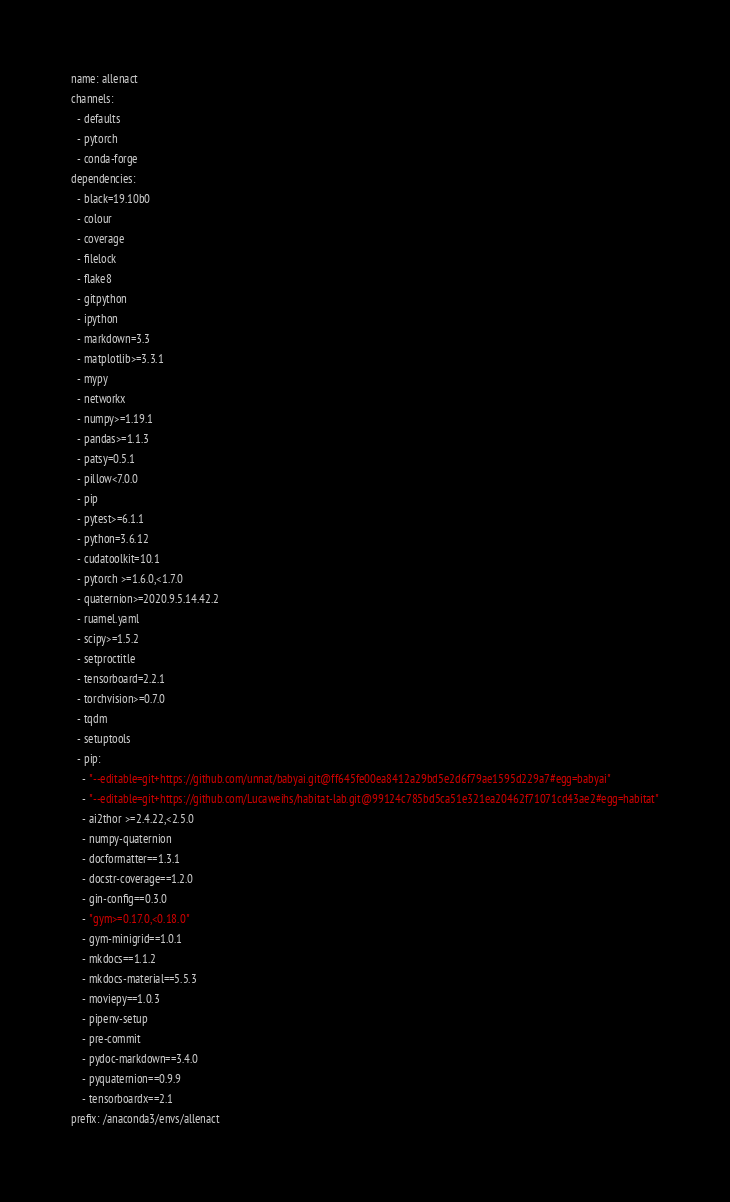<code> <loc_0><loc_0><loc_500><loc_500><_YAML_>name: allenact
channels:
  - defaults
  - pytorch
  - conda-forge
dependencies:
  - black=19.10b0
  - colour
  - coverage
  - filelock
  - flake8
  - gitpython
  - ipython
  - markdown=3.3
  - matplotlib>=3.3.1
  - mypy
  - networkx
  - numpy>=1.19.1
  - pandas>=1.1.3
  - patsy=0.5.1
  - pillow<7.0.0
  - pip
  - pytest>=6.1.1
  - python=3.6.12
  - cudatoolkit=10.1
  - pytorch >=1.6.0,<1.7.0
  - quaternion>=2020.9.5.14.42.2
  - ruamel.yaml
  - scipy>=1.5.2
  - setproctitle
  - tensorboard=2.2.1
  - torchvision>=0.7.0
  - tqdm
  - setuptools
  - pip:
    - "--editable=git+https://github.com/unnat/babyai.git@ff645fe00ea8412a29bd5e2d6f79ae1595d229a7#egg=babyai"
    - "--editable=git+https://github.com/Lucaweihs/habitat-lab.git@99124c785bd5ca51e321ea20462f71071cd43ae2#egg=habitat"
    - ai2thor >=2.4.22,<2.5.0
    - numpy-quaternion
    - docformatter==1.3.1
    - docstr-coverage==1.2.0
    - gin-config==0.3.0
    - "gym>=0.17.0,<0.18.0"
    - gym-minigrid==1.0.1
    - mkdocs==1.1.2
    - mkdocs-material==5.5.3
    - moviepy==1.0.3
    - pipenv-setup
    - pre-commit
    - pydoc-markdown==3.4.0
    - pyquaternion==0.9.9
    - tensorboardx==2.1
prefix: /anaconda3/envs/allenact
</code> 